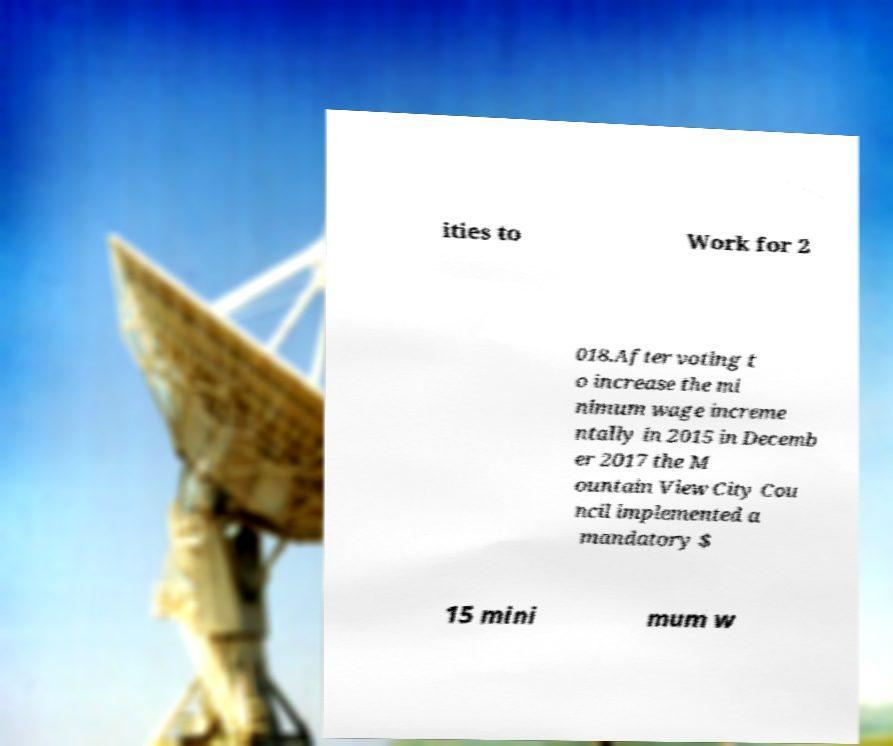What messages or text are displayed in this image? I need them in a readable, typed format. ities to Work for 2 018.After voting t o increase the mi nimum wage increme ntally in 2015 in Decemb er 2017 the M ountain View City Cou ncil implemented a mandatory $ 15 mini mum w 